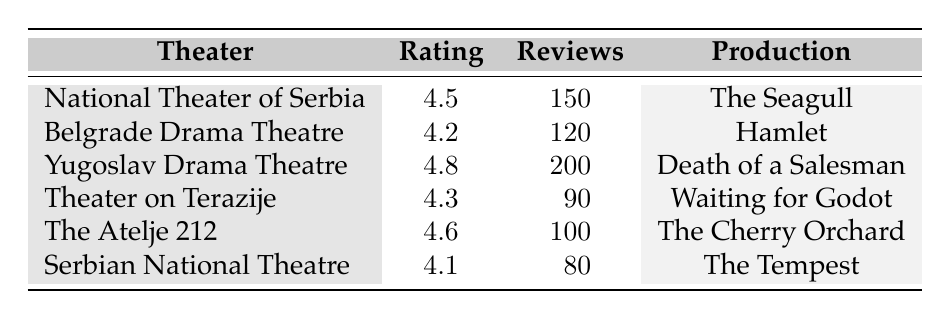What is the highest audience rating among the productions listed? The highest rating in the table is 4.8, which corresponds to "Death of a Salesman" at the Yugoslav Drama Theatre.
Answer: 4.8 Which theater received the lowest rating? According to the table, the Serbian National Theatre has the lowest rating of 4.1 for the production "The Tempest."
Answer: Serbian National Theatre How many reviews were submitted for "The Seagull"? The number of reviews for "The Seagull," performed by the National Theater of Serbia, is stated as 150 in the table.
Answer: 150 What is the average rating of all the productions? To calculate the average rating, sum the ratings (4.5 + 4.2 + 4.8 + 4.3 + 4.6 + 4.1 = 26.5) and divide by the number of productions (6). Therefore, the average rating is 26.5 / 6 = 4.42.
Answer: 4.42 Did any production receive more than 150 reviews? Yes, the production "Death of a Salesman" at the Yugoslav Drama Theatre received 200 reviews, which is more than 150.
Answer: Yes Which theater showcased "Waiting for Godot"? The theater showcasing "Waiting for Godot" is the Theater on Terazije according to the table.
Answer: Theater on Terazije How many more reviews did "Death of a Salesman" receive compared to "The Tempest"? The number of reviews for "Death of a Salesman" is 200, while for "The Tempest," it is 80. Subtracting gives a difference of 200 - 80 = 120 reviews.
Answer: 120 Is "Hamlet" the production with the highest number of reviews? No, "Hamlet" has 120 reviews, which is less than "Death of a Salesman," which received 200 reviews.
Answer: No What is the total count of reviews across all productions? To find the total, add the number of reviews from each production (150 + 120 + 200 + 90 + 100 + 80 = 830). The total number of reviews across all productions is 830.
Answer: 830 